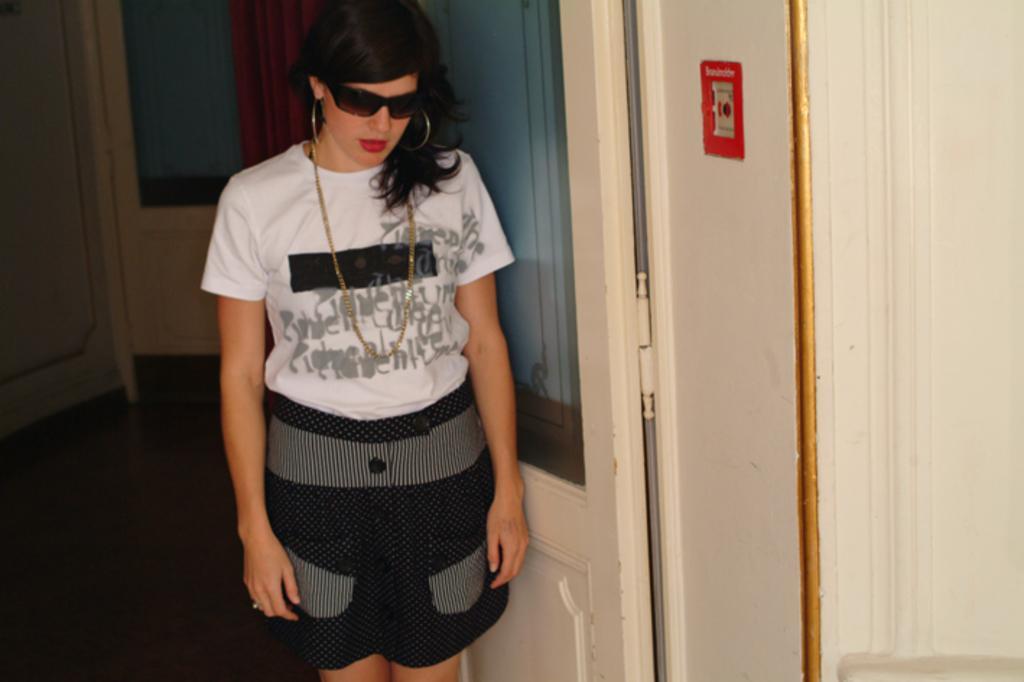Can you describe this image briefly? This image is taken indoors. In the middle of the image a woman is standing on the floor. In the background there is a wall with doors and a curtain. 